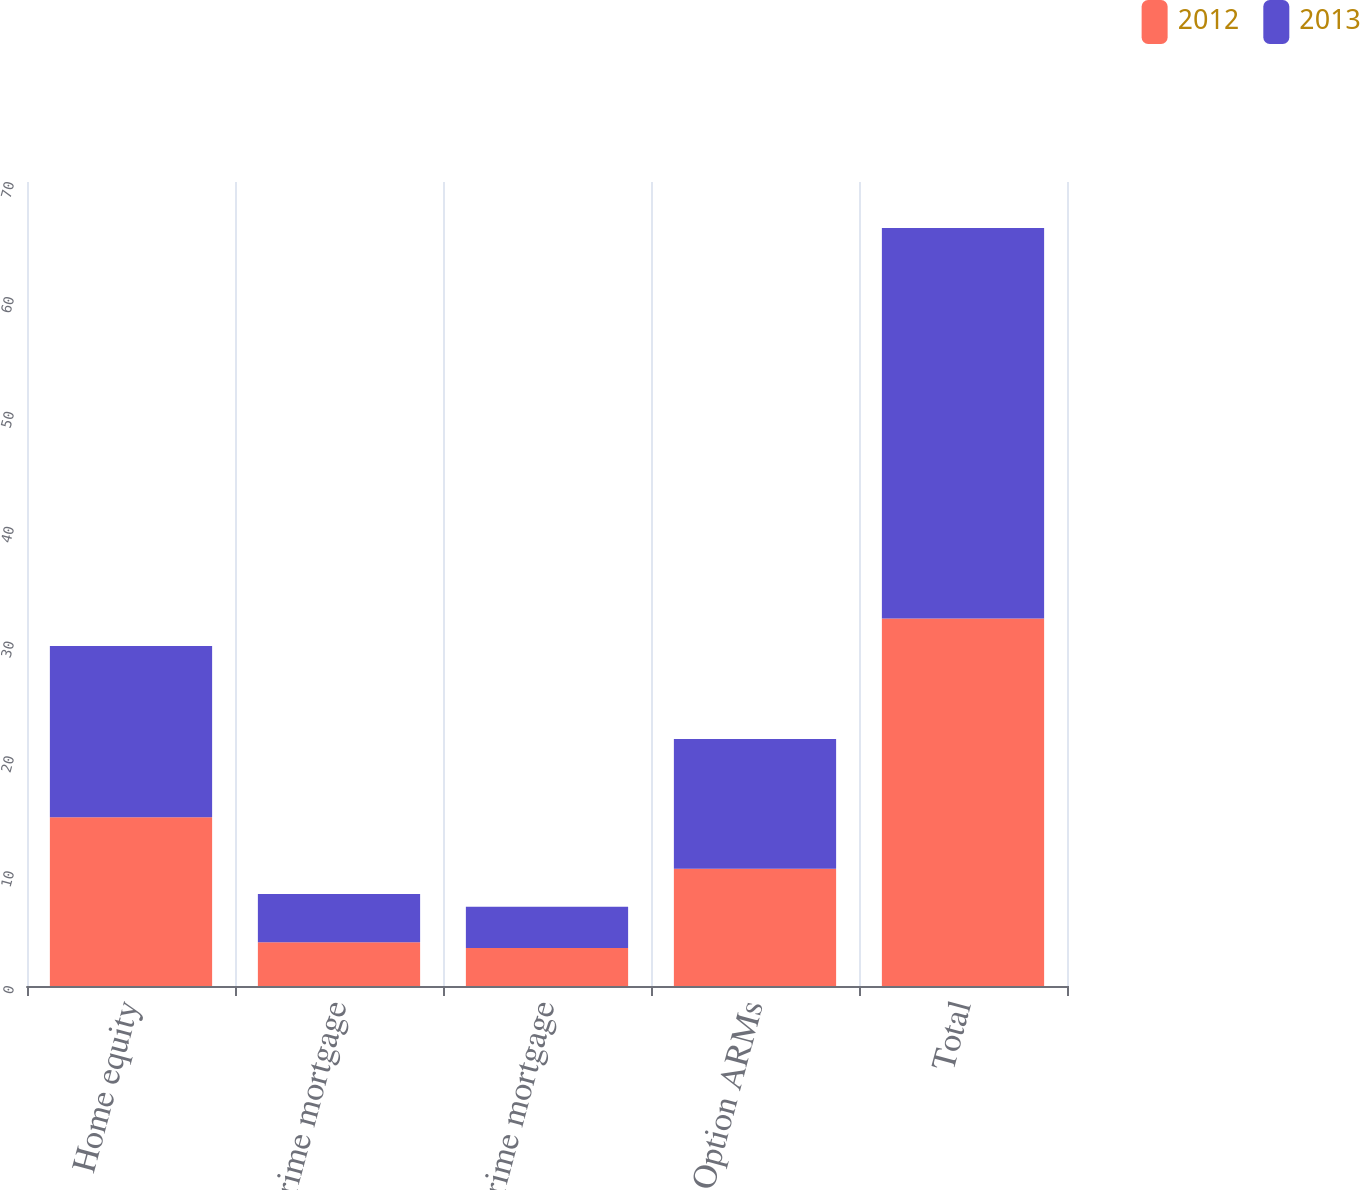Convert chart to OTSL. <chart><loc_0><loc_0><loc_500><loc_500><stacked_bar_chart><ecel><fcel>Home equity<fcel>Prime mortgage<fcel>Subprime mortgage<fcel>Option ARMs<fcel>Total<nl><fcel>2012<fcel>14.7<fcel>3.8<fcel>3.3<fcel>10.2<fcel>32<nl><fcel>2013<fcel>14.9<fcel>4.2<fcel>3.6<fcel>11.3<fcel>34<nl></chart> 